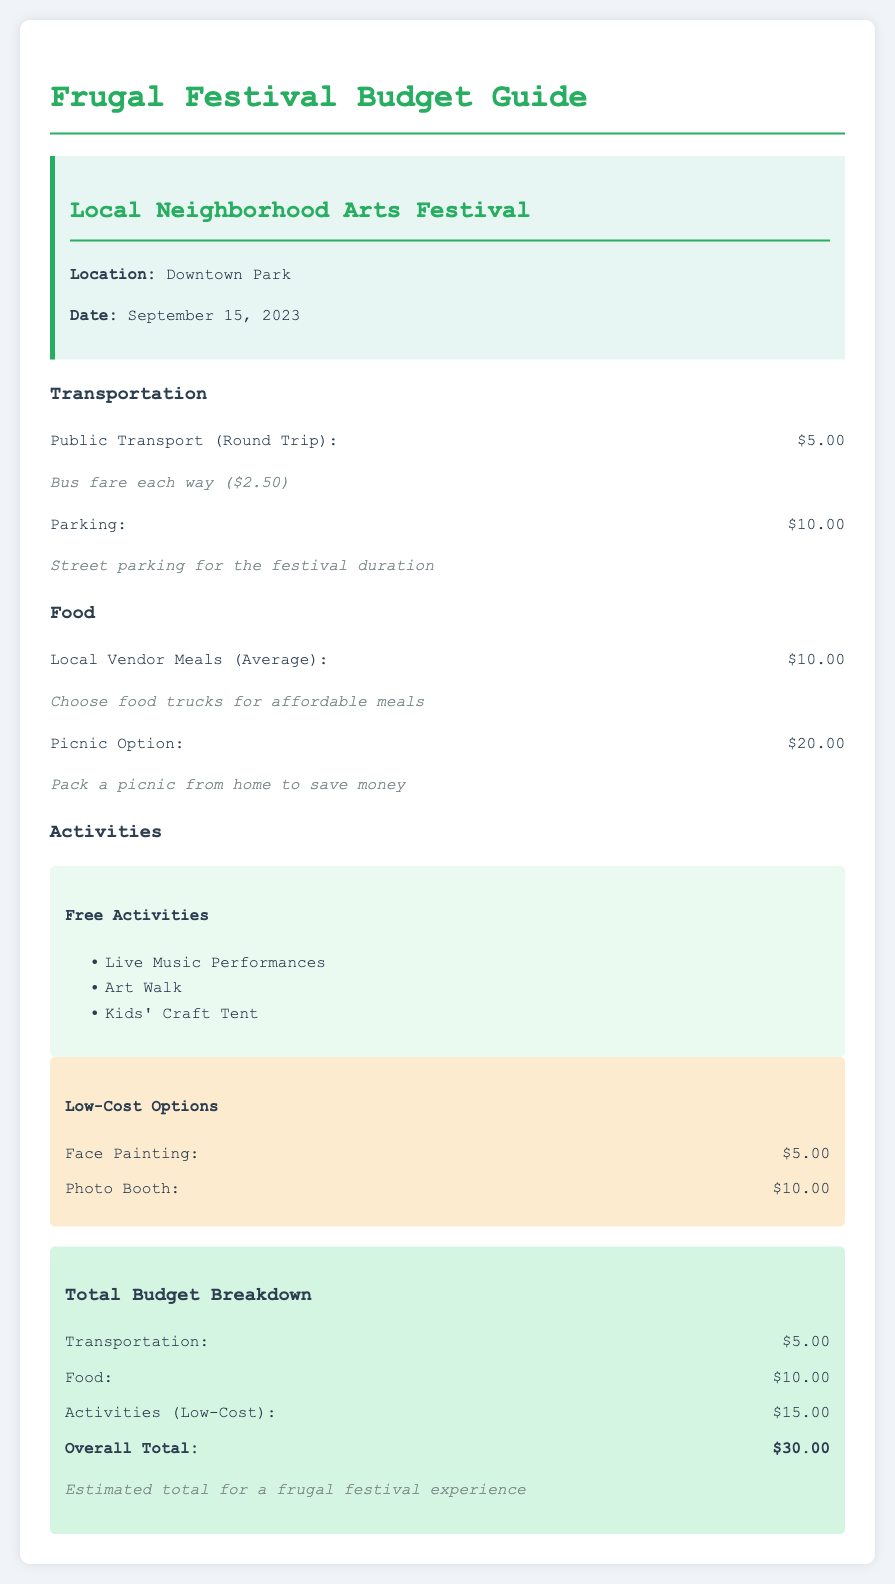What is the location of the festival? The location of the festival is stated in the document as Downtown Park.
Answer: Downtown Park When is the festival taking place? The document specifies that the festival is on September 15, 2023.
Answer: September 15, 2023 How much is the total budget for the festival? The total budget is clearly indicated in the document as $30.00.
Answer: $30.00 What is the average cost of a meal from local vendors? The document mentions that the average cost of local vendor meals is $10.00.
Answer: $10.00 What free activity can attendees participate in? The document lists several free activities, such as Live Music Performances.
Answer: Live Music Performances What is the cost of face painting at the festival? The document specifies that face painting costs $5.00.
Answer: $5.00 How much can attendees save by bringing a picnic? By packing a picnic from home, attendees can save money, but the document doesn't specify an exact amount saved.
Answer: Not specified What is the cost for parking at the festival? The document states that parking costs $10.00.
Answer: $10.00 Which activity has the highest cost listed? The highest cost listed in the activities section is the Photo Booth at $10.00.
Answer: Photo Booth 